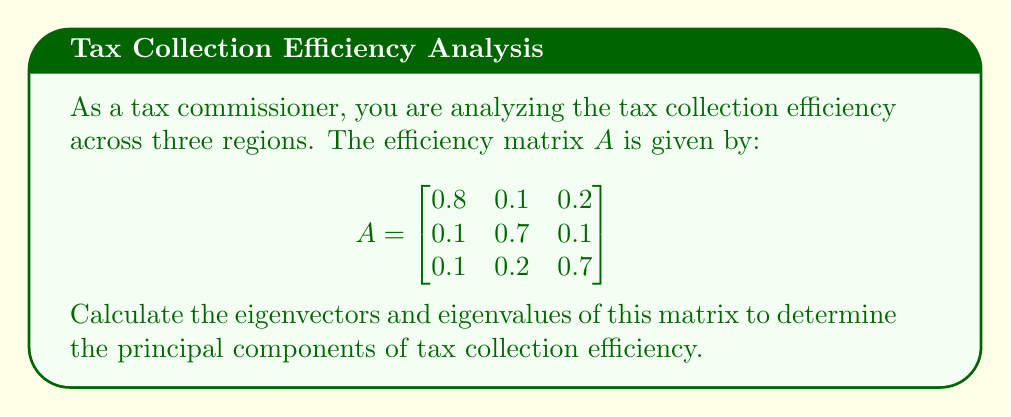Provide a solution to this math problem. To find the eigenvectors and eigenvalues of matrix $A$, we follow these steps:

1) Find the characteristic equation:
   $det(A - \lambda I) = 0$

   $$\begin{vmatrix}
   0.8-\lambda & 0.1 & 0.2 \\
   0.1 & 0.7-\lambda & 0.1 \\
   0.1 & 0.2 & 0.7-\lambda
   \end{vmatrix} = 0$$

2) Expand the determinant:
   $(0.8-\lambda)[(0.7-\lambda)(0.7-\lambda)-0.02] - 0.1[0.1(0.7-\lambda)-0.02] + 0.2[0.1(0.1)-0.1(0.7-\lambda)] = 0$

3) Simplify:
   $-\lambda^3 + 2.2\lambda^2 - 1.51\lambda + 0.322 = 0$

4) Solve for $\lambda$. The roots are the eigenvalues:
   $\lambda_1 = 1$, $\lambda_2 = 0.6$, $\lambda_3 = 0.6$

5) For each eigenvalue, solve $(A - \lambda I)v = 0$ to find the corresponding eigenvector:

   For $\lambda_1 = 1$:
   $$\begin{bmatrix}
   -0.2 & 0.1 & 0.2 \\
   0.1 & -0.3 & 0.1 \\
   0.1 & 0.2 & -0.3
   \end{bmatrix} \begin{bmatrix} v_1 \\ v_2 \\ v_3 \end{bmatrix} = \begin{bmatrix} 0 \\ 0 \\ 0 \end{bmatrix}$$

   Solving this gives $v_1 = \begin{bmatrix} 1 \\ 1 \\ 1 \end{bmatrix}$

   For $\lambda_2 = \lambda_3 = 0.6$:
   $$\begin{bmatrix}
   0.2 & 0.1 & 0.2 \\
   0.1 & 0.1 & 0.1 \\
   0.1 & 0.2 & 0.1
   \end{bmatrix} \begin{bmatrix} v_1 \\ v_2 \\ v_3 \end{bmatrix} = \begin{bmatrix} 0 \\ 0 \\ 0 \end{bmatrix}$$

   Solving this gives two linearly independent eigenvectors:
   $v_2 = \begin{bmatrix} -1 \\ 1 \\ 0 \end{bmatrix}$ and $v_3 = \begin{bmatrix} -1 \\ 0 \\ 1 \end{bmatrix}$

6) Normalize the eigenvectors:
   $v_1 = \frac{1}{\sqrt{3}}\begin{bmatrix} 1 \\ 1 \\ 1 \end{bmatrix}$
   $v_2 = \frac{1}{\sqrt{2}}\begin{bmatrix} -1 \\ 1 \\ 0 \end{bmatrix}$
   $v_3 = \frac{1}{\sqrt{2}}\begin{bmatrix} -1 \\ 0 \\ 1 \end{bmatrix}$
Answer: Eigenvalues: $\lambda_1 = 1$, $\lambda_2 = \lambda_3 = 0.6$
Normalized eigenvectors: $v_1 = \frac{1}{\sqrt{3}}[1,1,1]^T$, $v_2 = \frac{1}{\sqrt{2}}[-1,1,0]^T$, $v_3 = \frac{1}{\sqrt{2}}[-1,0,1]^T$ 